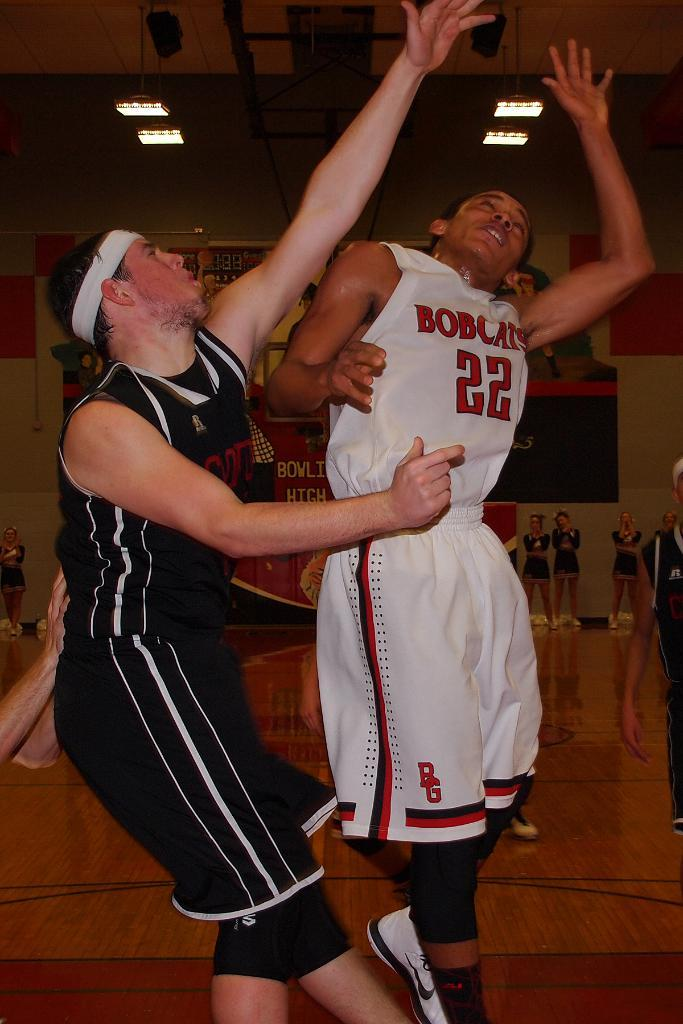<image>
Describe the image concisely. A basketball player wearing number 22 for the Bobcats is contesting a play with an opposing player. 